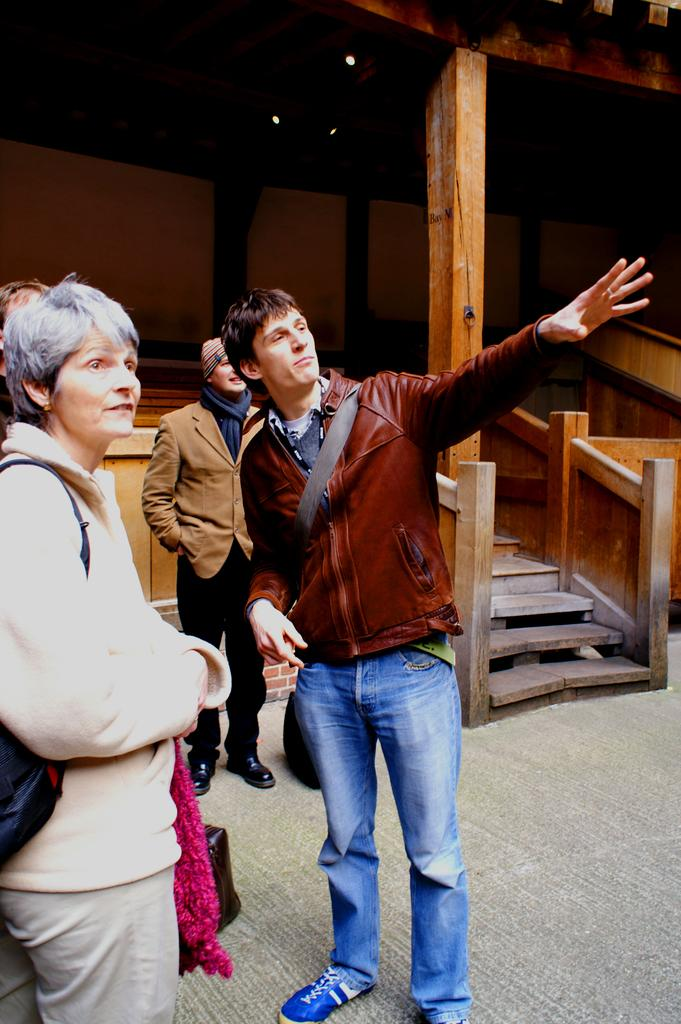Who or what is present in the image? There are people in the image. What are the people wearing? The people are wearing bags. What can be seen in the background of the image? There is a shed and stairs in the background of the image. What type of powder can be seen on the snail in the image? There is no snail or powder present in the image. 